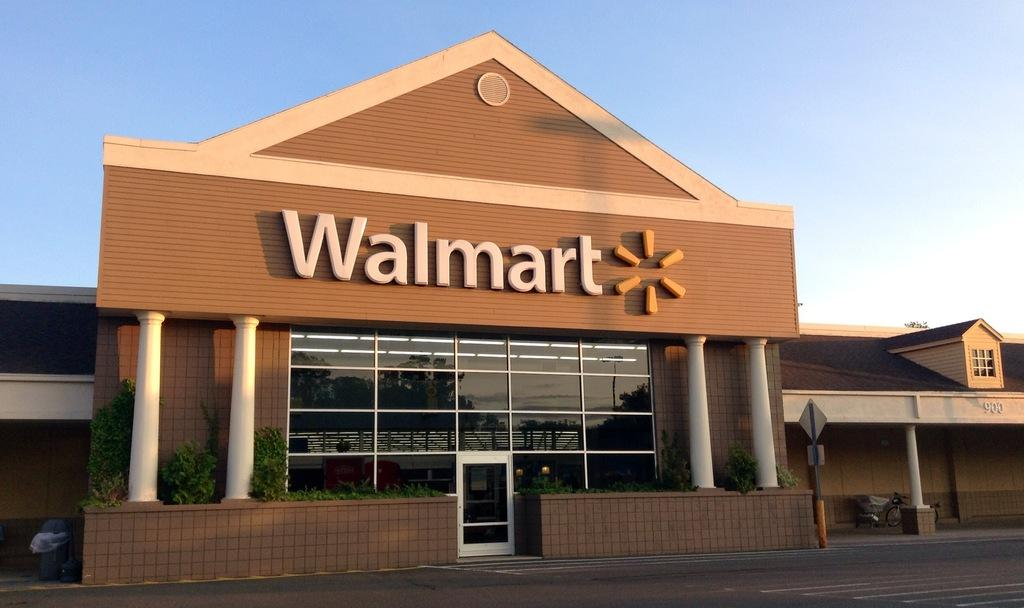What is located in the foreground of the image? There is a road in the foreground of the image. What can be seen in the middle of the image? There is a building, plants, a sign board, and other objects in the middle of the image. What is visible at the top of the image? The sky is visible at the top of the image. What type of authority is depicted on the sign board in the image? There is no authority depicted on the sign board in the image; it is not mentioned in the provided facts. Can you describe the creature that is interacting with the plants in the image? There is no creature present in the image; only the building, plants, sign board, and other objects are mentioned in the provided facts. 